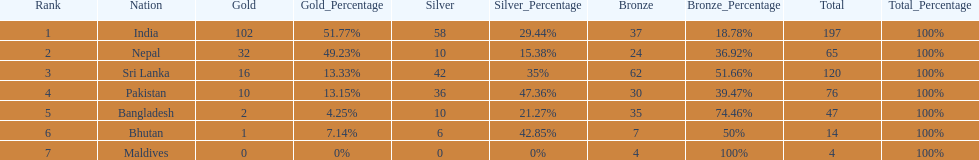What is the difference between the nation with the most medals and the nation with the least amount of medals? 193. 